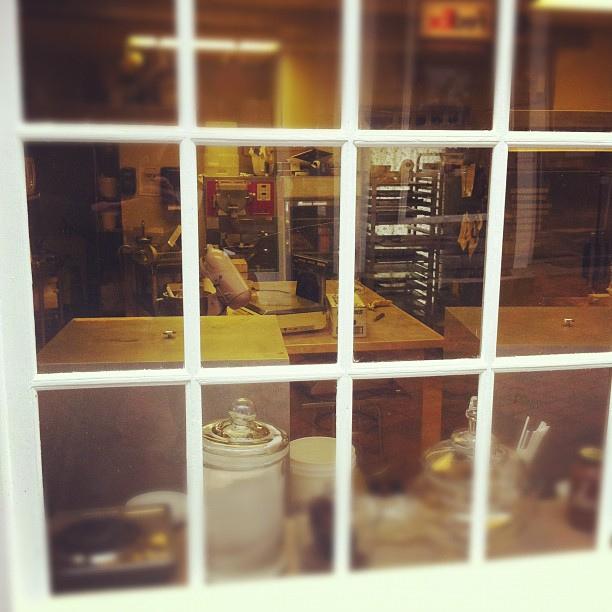Is the lid on the jar?
Quick response, please. Yes. Is this through a window?
Quick response, please. Yes. What is the photographer looking into?
Short answer required. Window. 